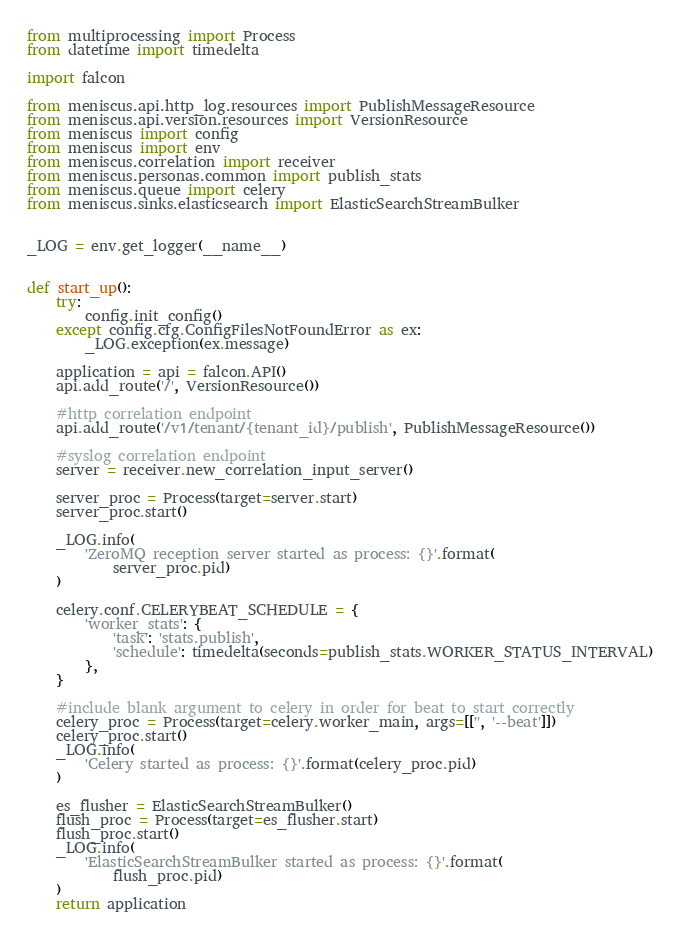Convert code to text. <code><loc_0><loc_0><loc_500><loc_500><_Python_>from multiprocessing import Process
from datetime import timedelta

import falcon

from meniscus.api.http_log.resources import PublishMessageResource
from meniscus.api.version.resources import VersionResource
from meniscus import config
from meniscus import env
from meniscus.correlation import receiver
from meniscus.personas.common import publish_stats
from meniscus.queue import celery
from meniscus.sinks.elasticsearch import ElasticSearchStreamBulker


_LOG = env.get_logger(__name__)


def start_up():
    try:
        config.init_config()
    except config.cfg.ConfigFilesNotFoundError as ex:
        _LOG.exception(ex.message)

    application = api = falcon.API()
    api.add_route('/', VersionResource())

    #http correlation endpoint
    api.add_route('/v1/tenant/{tenant_id}/publish', PublishMessageResource())

    #syslog correlation endpoint
    server = receiver.new_correlation_input_server()

    server_proc = Process(target=server.start)
    server_proc.start()

    _LOG.info(
        'ZeroMQ reception server started as process: {}'.format(
            server_proc.pid)
    )

    celery.conf.CELERYBEAT_SCHEDULE = {
        'worker_stats': {
            'task': 'stats.publish',
            'schedule': timedelta(seconds=publish_stats.WORKER_STATUS_INTERVAL)
        },
    }

    #include blank argument to celery in order for beat to start correctly
    celery_proc = Process(target=celery.worker_main, args=[['', '--beat']])
    celery_proc.start()
    _LOG.info(
        'Celery started as process: {}'.format(celery_proc.pid)
    )

    es_flusher = ElasticSearchStreamBulker()
    flush_proc = Process(target=es_flusher.start)
    flush_proc.start()
    _LOG.info(
        'ElasticSearchStreamBulker started as process: {}'.format(
            flush_proc.pid)
    )
    return application
</code> 